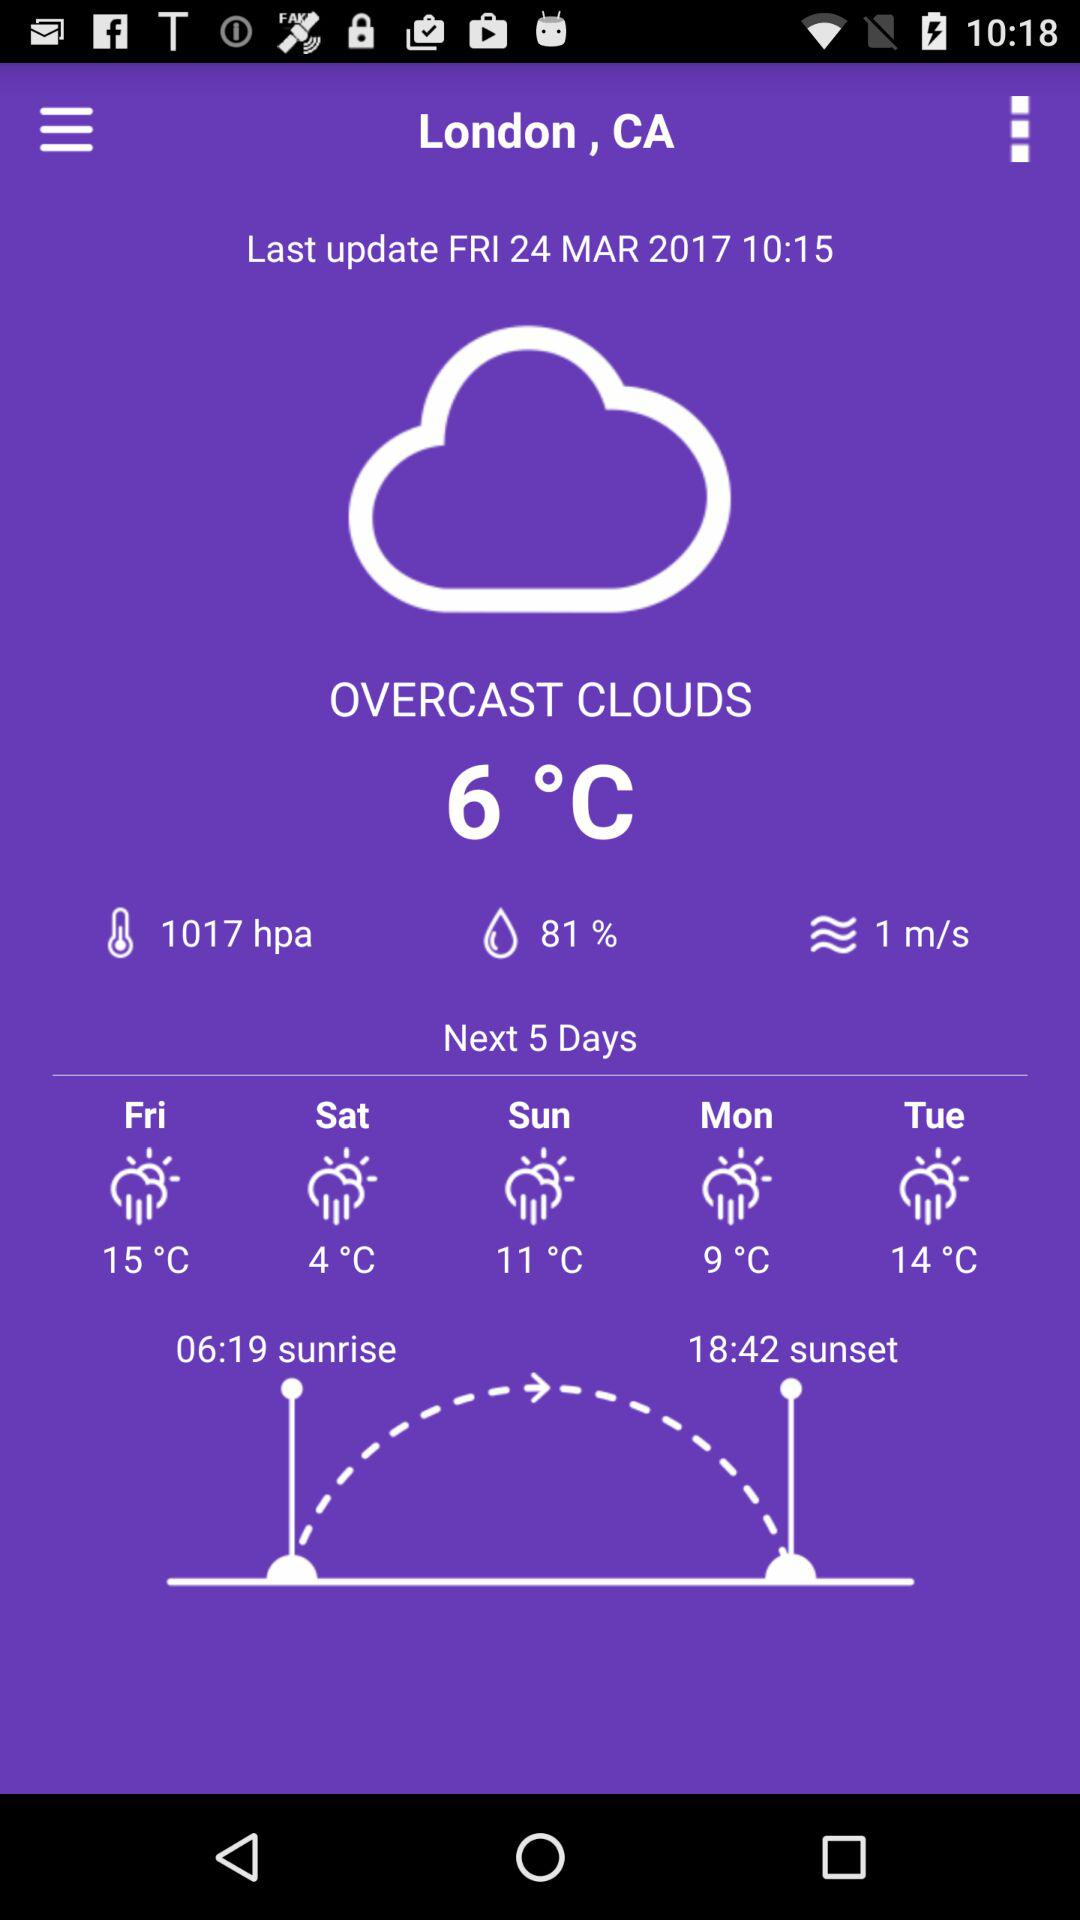How is the weather forecast for Sunday?
When the provided information is insufficient, respond with <no answer>. <no answer> 